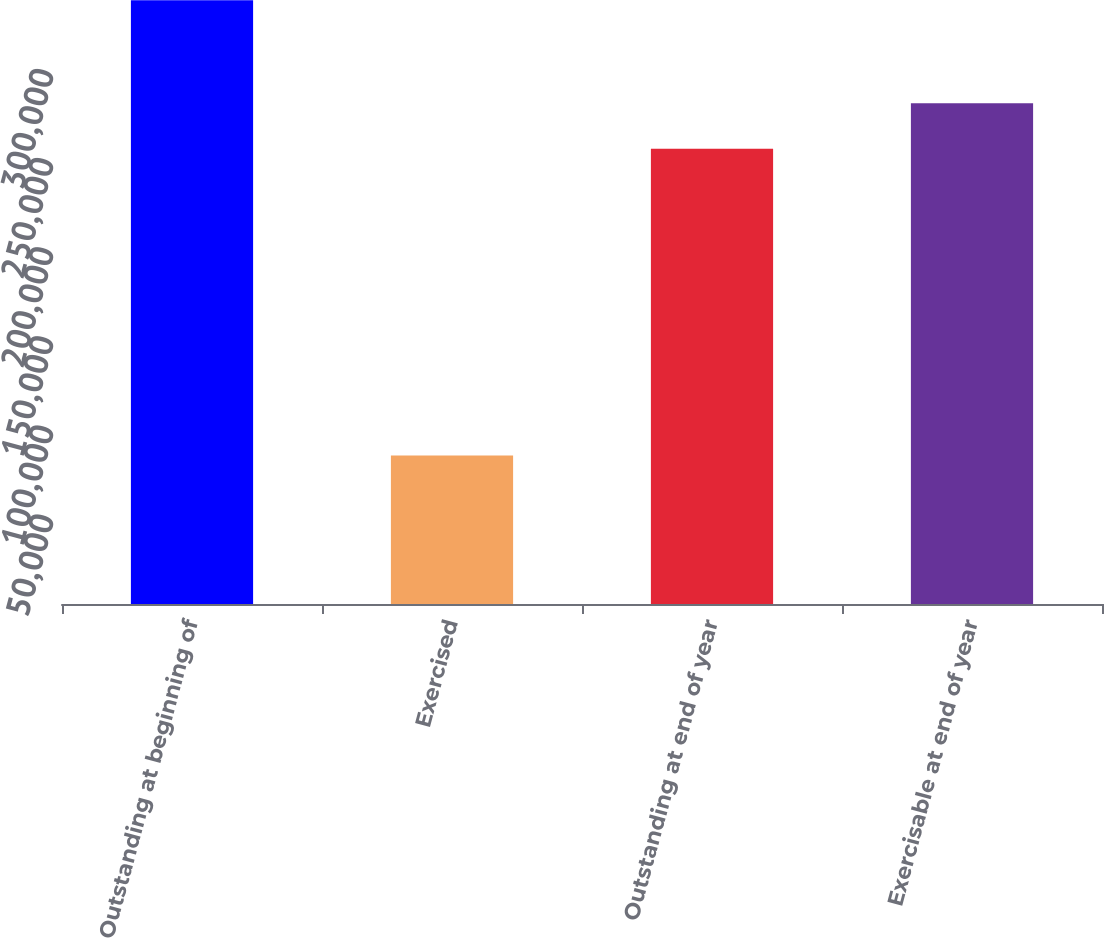Convert chart. <chart><loc_0><loc_0><loc_500><loc_500><bar_chart><fcel>Outstanding at beginning of<fcel>Exercised<fcel>Outstanding at end of year<fcel>Exercisable at end of year<nl><fcel>338680<fcel>83335<fcel>255345<fcel>280880<nl></chart> 